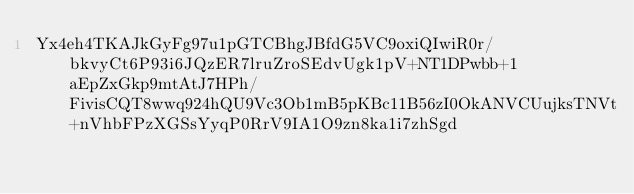Convert code to text. <code><loc_0><loc_0><loc_500><loc_500><_SML_>Yx4eh4TKAJkGyFg97u1pGTCBhgJBfdG5VC9oxiQIwiR0r/bkvyCt6P93i6JQzER7lruZroSEdvUgk1pV+NT1DPwbb+1aEpZxGkp9mtAtJ7HPh/FivisCQT8wwq924hQU9Vc3Ob1mB5pKBc11B56zI0OkANVCUujksTNVt+nVhbFPzXGSsYyqP0RrV9IA1O9zn8ka1i7zhSgd</code> 